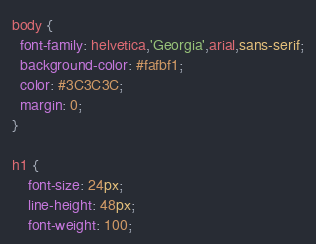<code> <loc_0><loc_0><loc_500><loc_500><_CSS_>body {
  font-family: helvetica,'Georgia',arial,sans-serif;
  background-color: #fafbf1;
  color: #3C3C3C;
  margin: 0;
}

h1 {
    font-size: 24px;
    line-height: 48px;
    font-weight: 100;</code> 